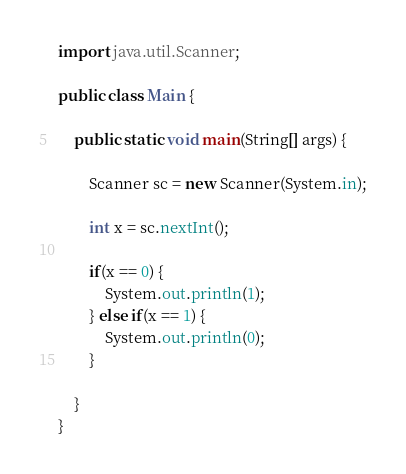Convert code to text. <code><loc_0><loc_0><loc_500><loc_500><_Java_>
import java.util.Scanner;

public class Main {

	public static void main(String[] args) {

		Scanner sc = new Scanner(System.in);

		int x = sc.nextInt();
		
		if(x == 0) {
			System.out.println(1);
		} else if(x == 1) {
			System.out.println(0);
		}
		
	}
}


</code> 